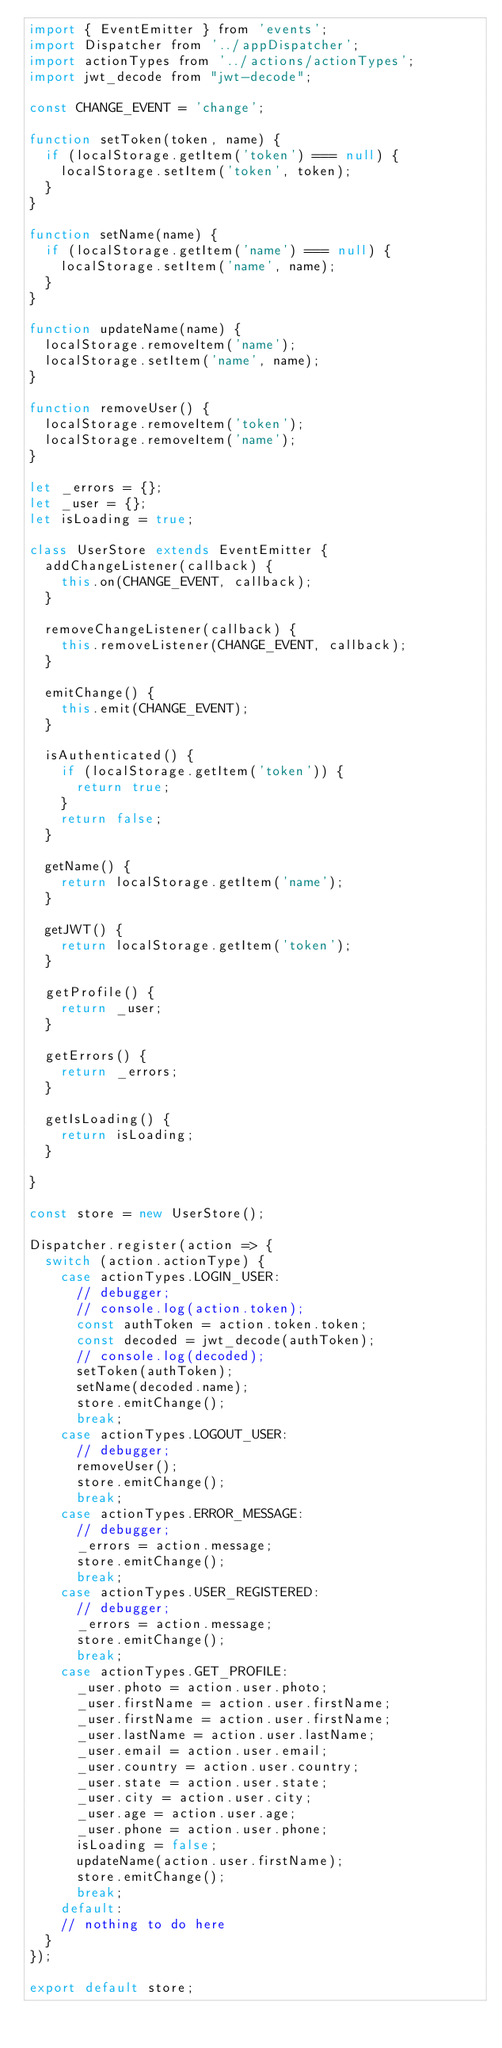<code> <loc_0><loc_0><loc_500><loc_500><_JavaScript_>import { EventEmitter } from 'events';
import Dispatcher from '../appDispatcher';
import actionTypes from '../actions/actionTypes';
import jwt_decode from "jwt-decode";

const CHANGE_EVENT = 'change';

function setToken(token, name) {
  if (localStorage.getItem('token') === null) {
    localStorage.setItem('token', token);
  }
}

function setName(name) {
  if (localStorage.getItem('name') === null) {
    localStorage.setItem('name', name);
  }
}

function updateName(name) {
  localStorage.removeItem('name');
  localStorage.setItem('name', name);
}

function removeUser() {
  localStorage.removeItem('token');
  localStorage.removeItem('name');
}

let _errors = {};
let _user = {};
let isLoading = true;

class UserStore extends EventEmitter {
  addChangeListener(callback) {
    this.on(CHANGE_EVENT, callback);
  }

  removeChangeListener(callback) {
    this.removeListener(CHANGE_EVENT, callback);
  }

  emitChange() {
    this.emit(CHANGE_EVENT);
  }

  isAuthenticated() {
    if (localStorage.getItem('token')) {
      return true;
    }
    return false;
  }

  getName() {
    return localStorage.getItem('name');
  }

  getJWT() {
    return localStorage.getItem('token');
  }

  getProfile() {
    return _user;
  }

  getErrors() {
    return _errors;
  }

  getIsLoading() {
    return isLoading;
  }

}

const store = new UserStore();

Dispatcher.register(action => {
  switch (action.actionType) {
    case actionTypes.LOGIN_USER:
      // debugger;
      // console.log(action.token);
      const authToken = action.token.token;
      const decoded = jwt_decode(authToken);
      // console.log(decoded);
      setToken(authToken);
      setName(decoded.name);
      store.emitChange();
      break;
    case actionTypes.LOGOUT_USER:
      // debugger;
      removeUser();
      store.emitChange();
      break;
    case actionTypes.ERROR_MESSAGE:
      // debugger;
      _errors = action.message;
      store.emitChange();
      break;
    case actionTypes.USER_REGISTERED:
      // debugger;
      _errors = action.message;
      store.emitChange();
      break;
    case actionTypes.GET_PROFILE:
      _user.photo = action.user.photo;
      _user.firstName = action.user.firstName;
      _user.firstName = action.user.firstName;
      _user.lastName = action.user.lastName;
      _user.email = action.user.email;
      _user.country = action.user.country;
      _user.state = action.user.state;
      _user.city = action.user.city;
      _user.age = action.user.age;
      _user.phone = action.user.phone;
      isLoading = false;
      updateName(action.user.firstName);
      store.emitChange();
      break;
    default:
    // nothing to do here
  }
});

export default store;</code> 